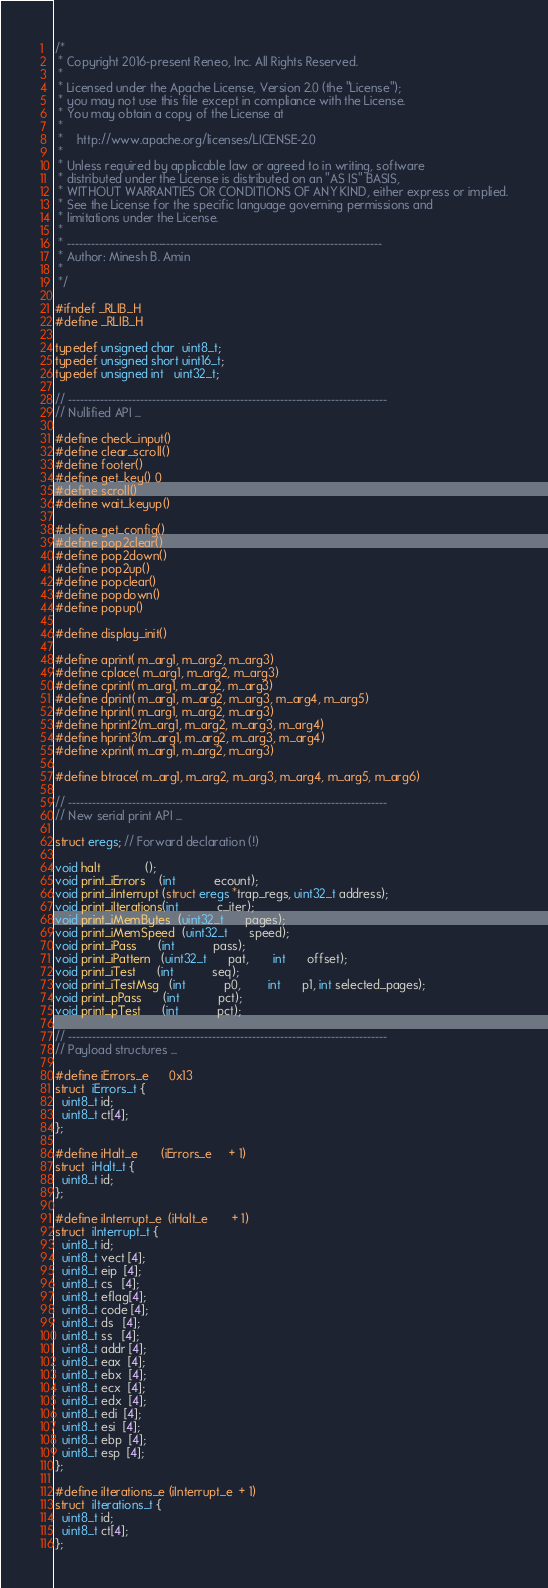Convert code to text. <code><loc_0><loc_0><loc_500><loc_500><_C_>/*
 * Copyright 2016-present Reneo, Inc. All Rights Reserved.
 *
 * Licensed under the Apache License, Version 2.0 (the "License");
 * you may not use this file except in compliance with the License.
 * You may obtain a copy of the License at
 *
 *    http://www.apache.org/licenses/LICENSE-2.0
 *
 * Unless required by applicable law or agreed to in writing, software
 * distributed under the License is distributed on an "AS IS" BASIS,
 * WITHOUT WARRANTIES OR CONDITIONS OF ANY KIND, either express or implied.
 * See the License for the specific language governing permissions and
 * limitations under the License.
 *
 * -------------------------------------------------------------------------------
 * Author: Minesh B. Amin
 *
 */

#ifndef _RLIB_H
#define _RLIB_H

typedef unsigned char  uint8_t;
typedef unsigned short uint16_t;
typedef unsigned int   uint32_t;

// --------------------------------------------------------------------------------
// Nullified API ...

#define check_input()
#define clear_scroll()
#define footer()
#define get_key() 0
#define scroll()
#define wait_keyup()

#define get_config()
#define pop2clear()
#define pop2down()
#define pop2up()
#define popclear()
#define popdown()
#define popup()

#define display_init()

#define aprint( m_arg1, m_arg2, m_arg3)
#define cplace( m_arg1, m_arg2, m_arg3)
#define cprint( m_arg1, m_arg2, m_arg3)
#define dprint( m_arg1, m_arg2, m_arg3, m_arg4, m_arg5)
#define hprint( m_arg1, m_arg2, m_arg3)
#define hprint2(m_arg1, m_arg2, m_arg3, m_arg4)
#define hprint3(m_arg1, m_arg2, m_arg3, m_arg4)
#define xprint( m_arg1, m_arg2, m_arg3)

#define btrace( m_arg1, m_arg2, m_arg3, m_arg4, m_arg5, m_arg6)

// --------------------------------------------------------------------------------
// New serial print API ...

struct eregs; // Forward declaration (!)

void halt             ();
void print_iErrors    (int           ecount);
void print_iInterrupt (struct eregs *trap_regs, uint32_t address);
void print_iIterations(int           c_iter);
void print_iMemBytes  (uint32_t      pages);
void print_iMemSpeed  (uint32_t      speed);
void print_iPass      (int           pass);
void print_iPattern   (uint32_t      pat,       int      offset);
void print_iTest      (int           seq);
void print_iTestMsg   (int           p0,        int      p1, int selected_pages);
void print_pPass      (int           pct);
void print_pTest      (int           pct);

// --------------------------------------------------------------------------------
// Payload structures ...

#define iErrors_e      0x13
struct  iErrors_t {
  uint8_t id;
  uint8_t ct[4];
};

#define iHalt_e       (iErrors_e     + 1)
struct  iHalt_t {
  uint8_t id;
};

#define iInterrupt_e  (iHalt_e       + 1)
struct  iInterrupt_t {
  uint8_t id;
  uint8_t vect [4];
  uint8_t eip  [4];
  uint8_t cs   [4];
  uint8_t eflag[4];
  uint8_t code [4];
  uint8_t ds   [4];
  uint8_t ss   [4];
  uint8_t addr [4];
  uint8_t eax  [4];
  uint8_t ebx  [4];
  uint8_t ecx  [4];
  uint8_t edx  [4];
  uint8_t edi  [4];
  uint8_t esi  [4];
  uint8_t ebp  [4];
  uint8_t esp  [4];
};

#define iIterations_e (iInterrupt_e  + 1)
struct  iIterations_t {
  uint8_t id;
  uint8_t ct[4];
};
</code> 